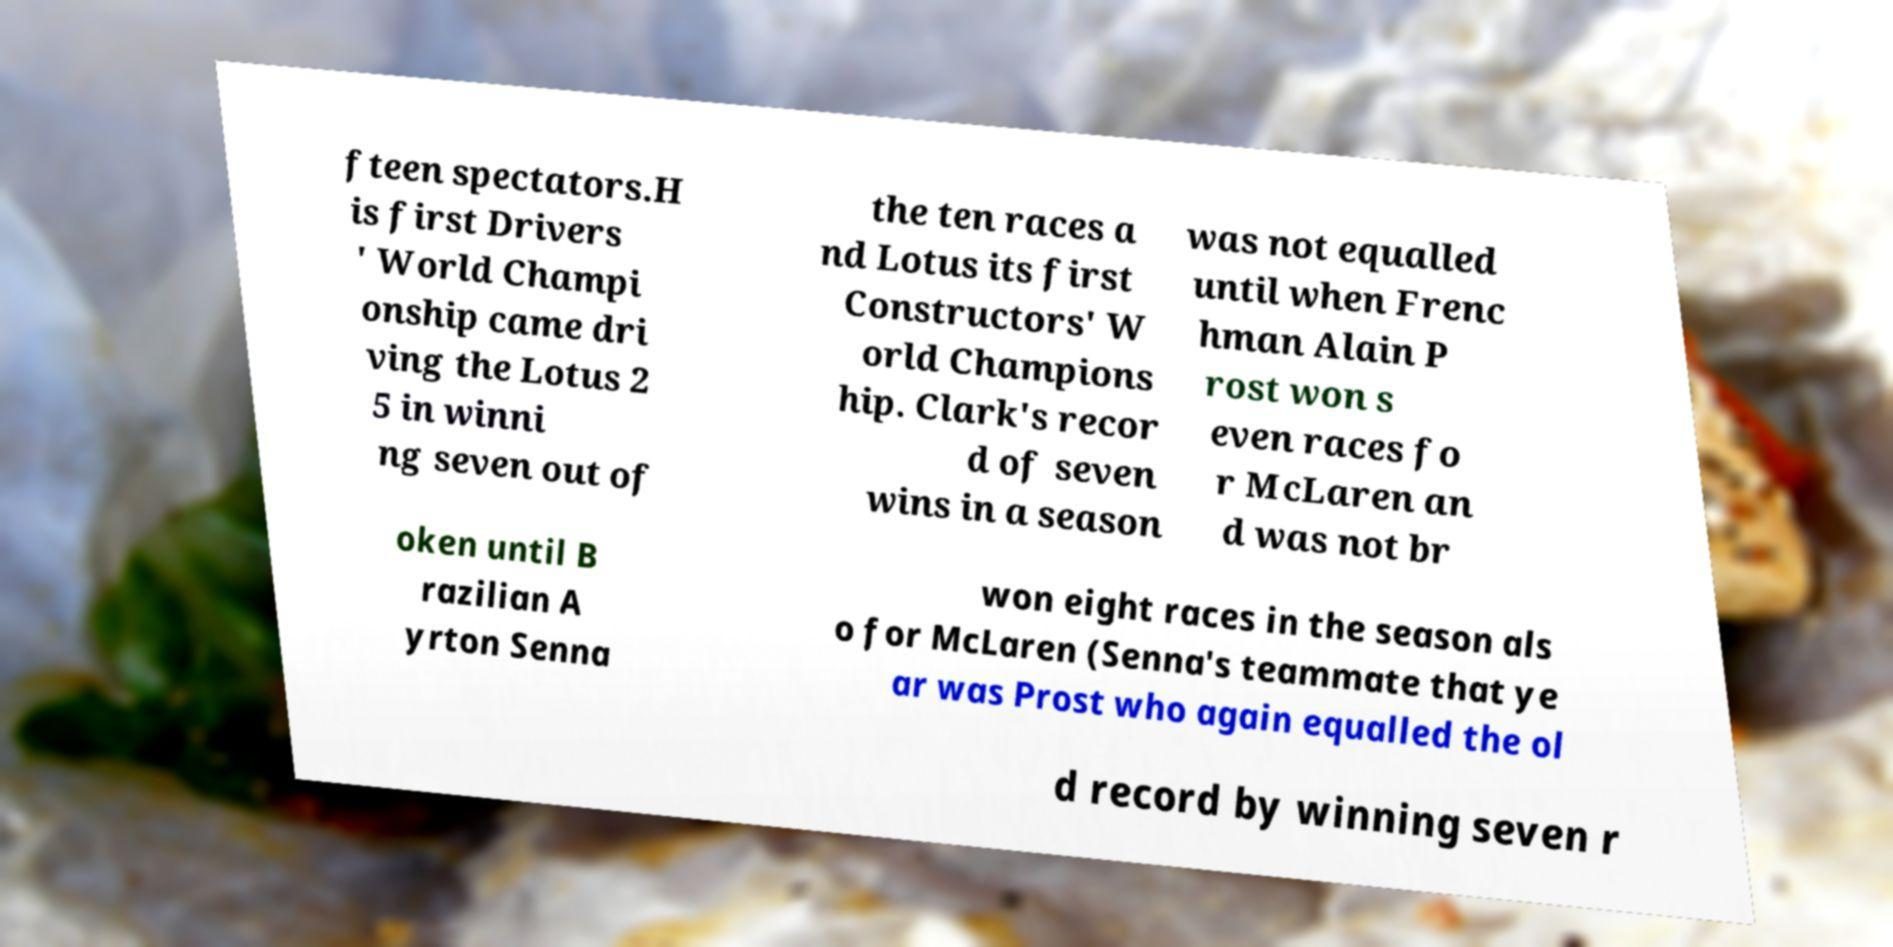There's text embedded in this image that I need extracted. Can you transcribe it verbatim? fteen spectators.H is first Drivers ' World Champi onship came dri ving the Lotus 2 5 in winni ng seven out of the ten races a nd Lotus its first Constructors' W orld Champions hip. Clark's recor d of seven wins in a season was not equalled until when Frenc hman Alain P rost won s even races fo r McLaren an d was not br oken until B razilian A yrton Senna won eight races in the season als o for McLaren (Senna's teammate that ye ar was Prost who again equalled the ol d record by winning seven r 